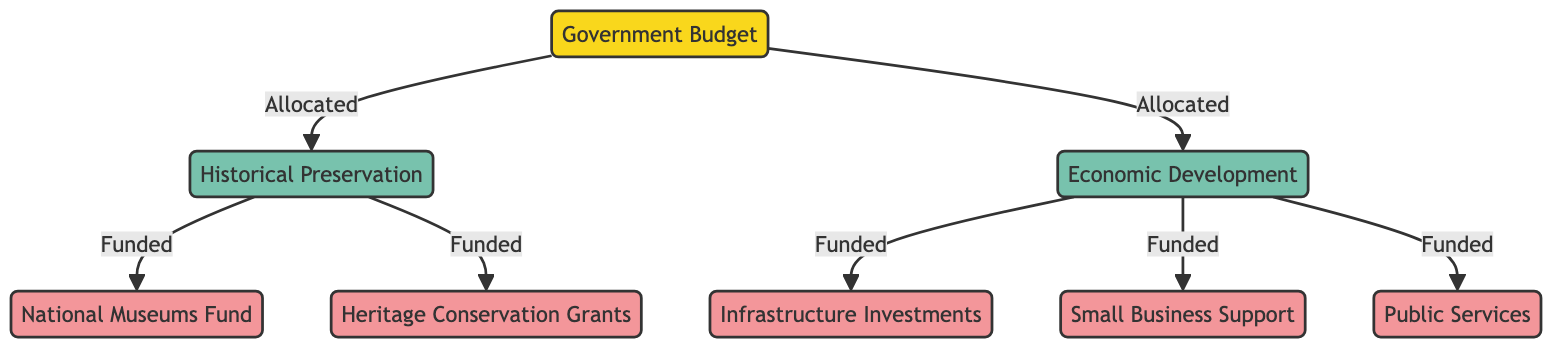What are the two categories that receive funds from the Government Budget? The categories that receive funds from the Government Budget are Historical Preservation and Economic Development, as indicated by the two directed edges leading out of the Government Budget node.
Answer: Historical Preservation, Economic Development How many funds are allocated specifically to Historical Preservation? There are two funds linked to Historical Preservation: National Museums Fund and Heritage Conservation Grants, which are represented by the two directed edges flowing from the Historical Preservation node.
Answer: 2 What is one fund that is receiving funding from Economic Development? Economic Development funds three specific projects or initiatives: Infrastructure Investments, Small Business Support, and Public Services. Any one of these could be the answer. Here, we'll choose one for clarity.
Answer: Infrastructure Investments Does the Government Budget allocate funds to both categories? Yes, the diagram indicates that the Government Budget allocates funds to both Historical Preservation and Economic Development, as shown by the directed edges connecting to both categories.
Answer: Yes Which category has more funded projects available according to the diagram? The Economic Development category has three funded projects (Infrastructure Investments, Small Business Support, Public Services), whereas Historical Preservation has two funded projects. Therefore, Economic Development has more.
Answer: Economic Development How many total nodes are present in the diagram? The total number of nodes in the diagram is seven: the Government Budget, Historical Preservation, Economic Development, and four funds (National Museums Fund, Heritage Conservation Grants, Infrastructure Investments, Small Business Support, and Public Services).
Answer: 7 What is the flow direction of funds from Historical Preservation? The flow direction of funds from Historical Preservation is towards the two funds it supports, indicating a one-way contribution of resources. Thus, the funds receive allocations from this category.
Answer: Outward Which node receives funds from the Economic Development category? Economic Development directly funds three projects, indicated by the outgoing edges from it to Infrastructure Investments, Small Business Support, and Public Services.
Answer: Infrastructure Investments What type of graph is represented by this diagram? This diagram is a Directed Graph, as it illustrates the flow of funds with directed edges showing the allocation and funding relationships among the various nodes.
Answer: Directed Graph 